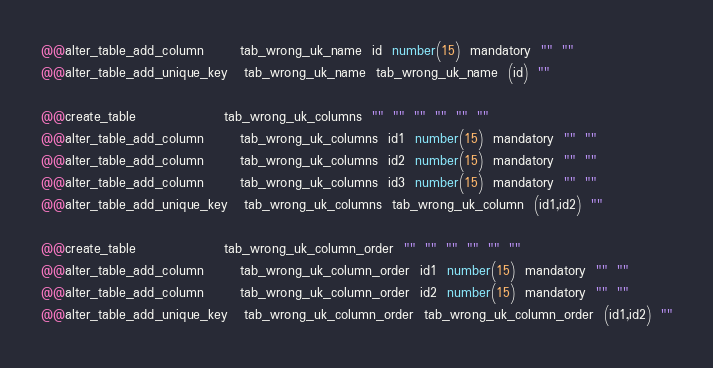Convert code to text. <code><loc_0><loc_0><loc_500><loc_500><_SQL_>@@alter_table_add_column       tab_wrong_uk_name  id  number(15)  mandatory  ""  ""  
@@alter_table_add_unique_key   tab_wrong_uk_name  tab_wrong_uk_name  (id)  ""

@@create_table                 tab_wrong_uk_columns  ""  ""  ""  ""  ""  ""
@@alter_table_add_column       tab_wrong_uk_columns  id1  number(15)  mandatory  ""  ""  
@@alter_table_add_column       tab_wrong_uk_columns  id2  number(15)  mandatory  ""  "" 
@@alter_table_add_column       tab_wrong_uk_columns  id3  number(15)  mandatory  ""  ""
@@alter_table_add_unique_key   tab_wrong_uk_columns  tab_wrong_uk_column  (id1,id2)  ""

@@create_table                 tab_wrong_uk_column_order  ""  ""  ""  ""  ""  ""
@@alter_table_add_column       tab_wrong_uk_column_order  id1  number(15)  mandatory  ""  ""  
@@alter_table_add_column       tab_wrong_uk_column_order  id2  number(15)  mandatory  ""  "" 
@@alter_table_add_unique_key   tab_wrong_uk_column_order  tab_wrong_uk_column_order  (id1,id2)  ""







</code> 